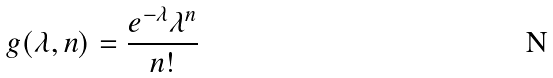<formula> <loc_0><loc_0><loc_500><loc_500>g ( \lambda , n ) = \frac { e ^ { - \lambda } \lambda ^ { n } } { n ! }</formula> 